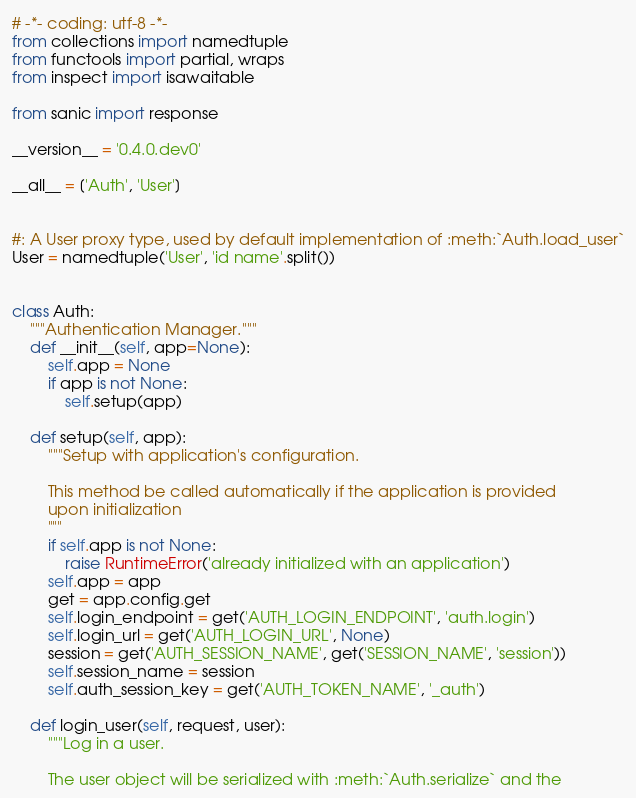Convert code to text. <code><loc_0><loc_0><loc_500><loc_500><_Python_># -*- coding: utf-8 -*-
from collections import namedtuple
from functools import partial, wraps
from inspect import isawaitable

from sanic import response

__version__ = '0.4.0.dev0'

__all__ = ['Auth', 'User']


#: A User proxy type, used by default implementation of :meth:`Auth.load_user`
User = namedtuple('User', 'id name'.split())


class Auth:
    """Authentication Manager."""
    def __init__(self, app=None):
        self.app = None
        if app is not None:
            self.setup(app)

    def setup(self, app):
        """Setup with application's configuration.

        This method be called automatically if the application is provided
        upon initialization
        """
        if self.app is not None:
            raise RuntimeError('already initialized with an application')
        self.app = app
        get = app.config.get
        self.login_endpoint = get('AUTH_LOGIN_ENDPOINT', 'auth.login')
        self.login_url = get('AUTH_LOGIN_URL', None)
        session = get('AUTH_SESSION_NAME', get('SESSION_NAME', 'session'))
        self.session_name = session
        self.auth_session_key = get('AUTH_TOKEN_NAME', '_auth')

    def login_user(self, request, user):
        """Log in a user.

        The user object will be serialized with :meth:`Auth.serialize` and the</code> 